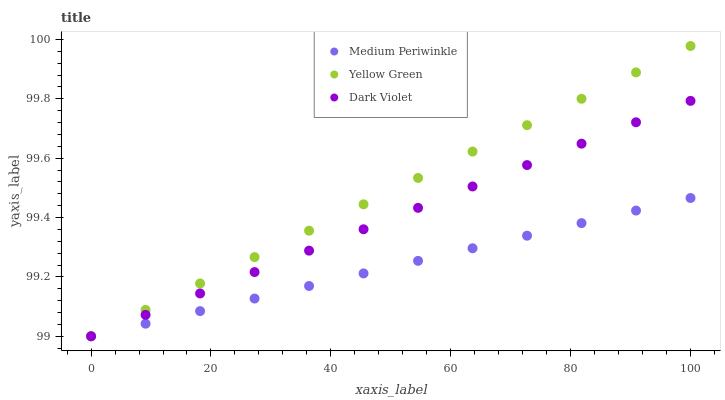Does Medium Periwinkle have the minimum area under the curve?
Answer yes or no. Yes. Does Yellow Green have the maximum area under the curve?
Answer yes or no. Yes. Does Dark Violet have the minimum area under the curve?
Answer yes or no. No. Does Dark Violet have the maximum area under the curve?
Answer yes or no. No. Is Yellow Green the smoothest?
Answer yes or no. Yes. Is Medium Periwinkle the roughest?
Answer yes or no. Yes. Is Dark Violet the smoothest?
Answer yes or no. No. Is Dark Violet the roughest?
Answer yes or no. No. Does Medium Periwinkle have the lowest value?
Answer yes or no. Yes. Does Yellow Green have the highest value?
Answer yes or no. Yes. Does Dark Violet have the highest value?
Answer yes or no. No. Does Medium Periwinkle intersect Yellow Green?
Answer yes or no. Yes. Is Medium Periwinkle less than Yellow Green?
Answer yes or no. No. Is Medium Periwinkle greater than Yellow Green?
Answer yes or no. No. 